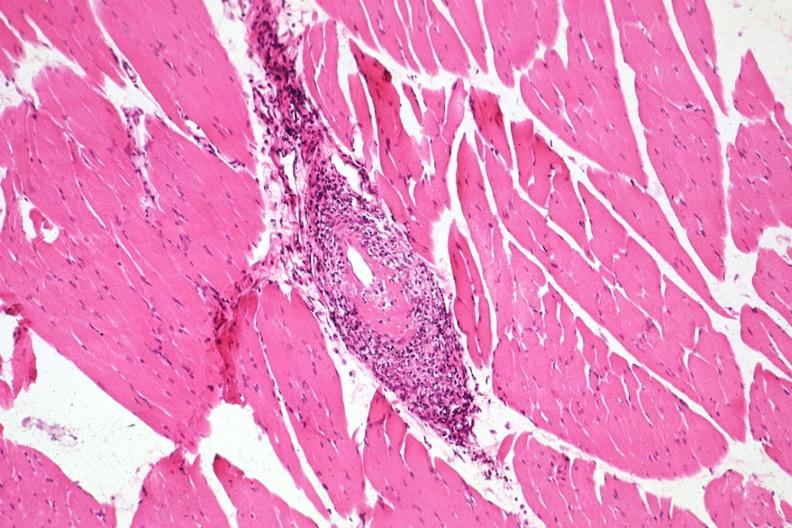does this image show typical acute lesion very good?
Answer the question using a single word or phrase. Yes 